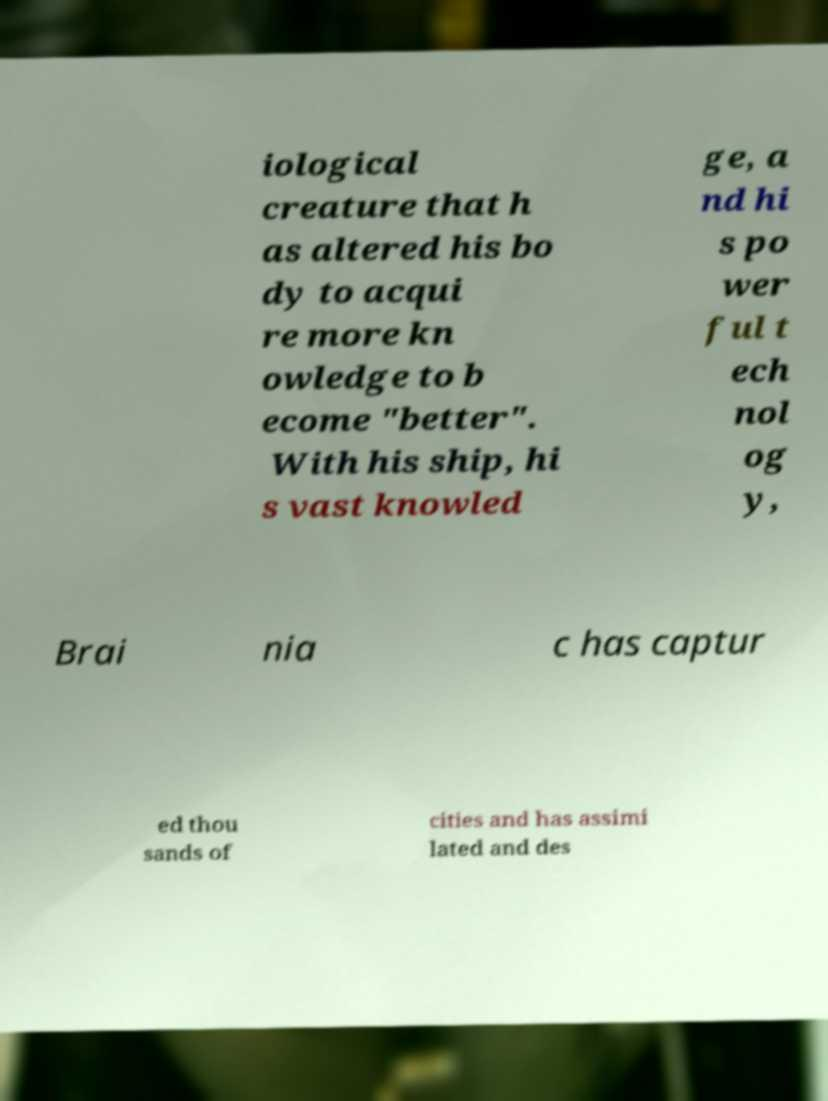I need the written content from this picture converted into text. Can you do that? iological creature that h as altered his bo dy to acqui re more kn owledge to b ecome "better". With his ship, hi s vast knowled ge, a nd hi s po wer ful t ech nol og y, Brai nia c has captur ed thou sands of cities and has assimi lated and des 